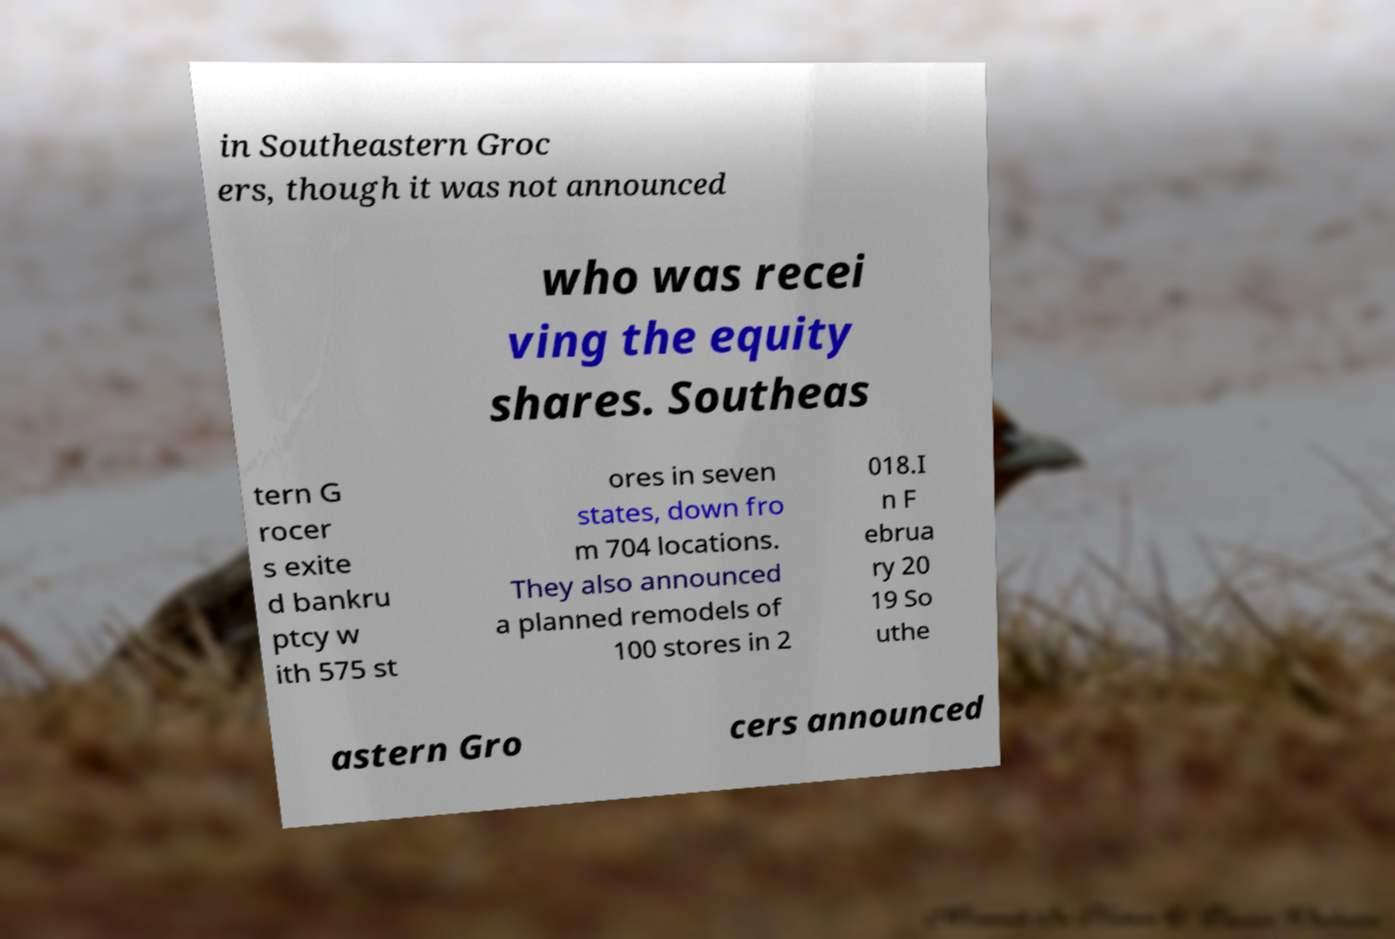There's text embedded in this image that I need extracted. Can you transcribe it verbatim? in Southeastern Groc ers, though it was not announced who was recei ving the equity shares. Southeas tern G rocer s exite d bankru ptcy w ith 575 st ores in seven states, down fro m 704 locations. They also announced a planned remodels of 100 stores in 2 018.I n F ebrua ry 20 19 So uthe astern Gro cers announced 